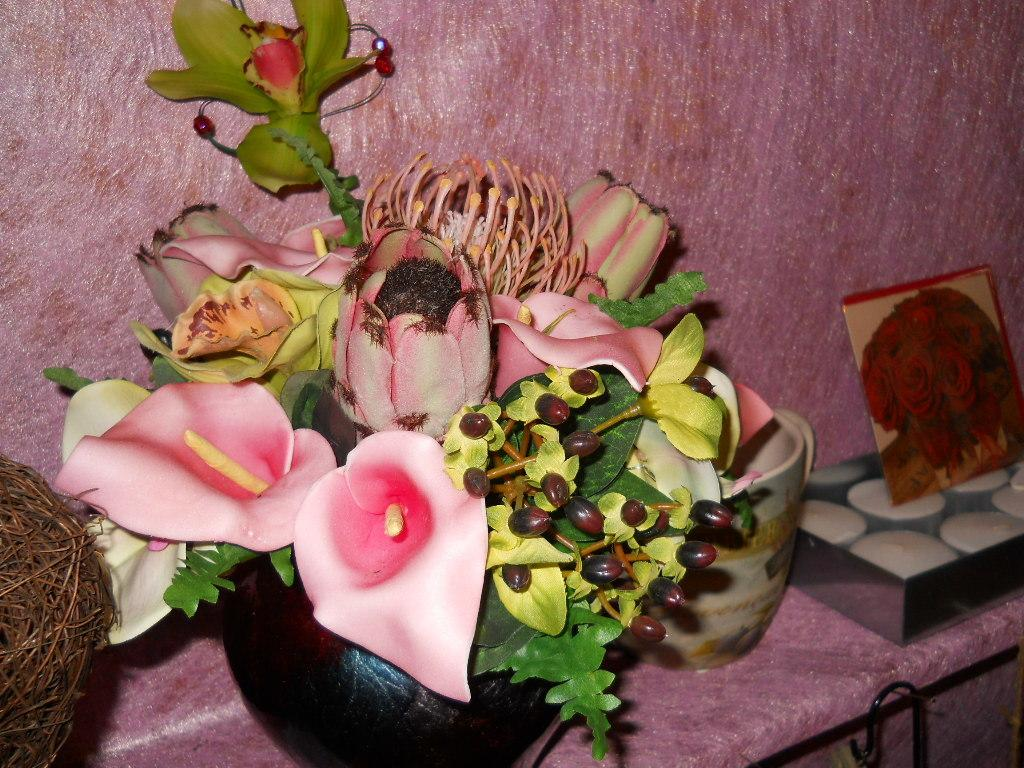What color is the table in the image? The table in the image is pink. What is on top of the table? There is a vase with flowers, a cup, a part of a nest, and a box on the table. What is on the box? There is a photo frame on the box. What can be seen in the background of the image? There is a pink wall in the background. How far away is the committee from the table in the image? There is no committee present in the image, so it is not possible to determine the distance between a committee and the table. 